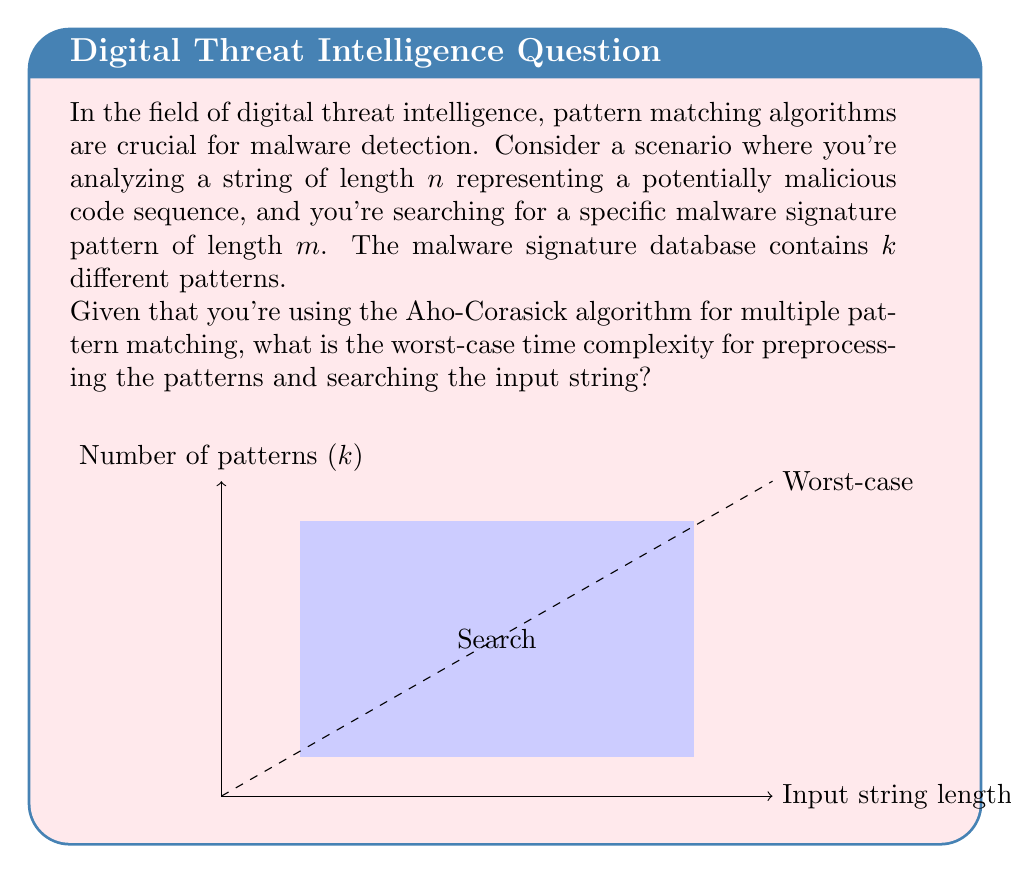Can you answer this question? To determine the worst-case complexity, we need to consider both the preprocessing phase and the search phase of the Aho-Corasick algorithm:

1. Preprocessing phase:
   - Building the trie: $O(L)$, where $L$ is the total length of all patterns.
   - Constructing failure links: $O(L \cdot |\Sigma|)$, where $|\Sigma|$ is the size of the alphabet.
   
   Since $L = O(m \cdot k)$, where $m$ is the length of the longest pattern, the preprocessing complexity is $O(m \cdot k \cdot |\Sigma|)$.

2. Search phase:
   - The Aho-Corasick algorithm processes each character of the input string exactly once.
   - For each character, it may follow failure links, but the total number of failure link traversals is bounded by the length of the input string.
   
   Therefore, the search complexity is $O(n + z)$, where $n$ is the length of the input string and $z$ is the number of pattern occurrences.

3. Combining preprocessing and search:
   The total worst-case time complexity is the sum of preprocessing and search complexities:
   
   $$O(m \cdot k \cdot |\Sigma| + n + z)$$

4. Simplification:
   - In practice, $|\Sigma|$ is often considered constant (e.g., ASCII or Unicode).
   - The number of occurrences $z$ is bounded by $n$ in the worst case.
   
   Therefore, we can simplify the complexity to:
   
   $$O(m \cdot k + n)$$

This represents the worst-case scenario where we need to preprocess all patterns and search through the entire input string.
Answer: $O(m \cdot k + n)$ 